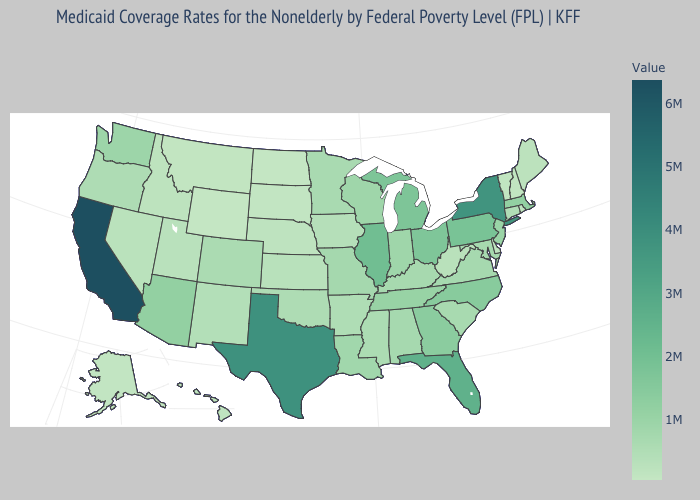Which states have the lowest value in the USA?
Concise answer only. Wyoming. Does Arizona have a higher value than California?
Be succinct. No. Is the legend a continuous bar?
Short answer required. Yes. Does the map have missing data?
Short answer required. No. Is the legend a continuous bar?
Write a very short answer. Yes. Does Minnesota have a higher value than Michigan?
Keep it brief. No. 